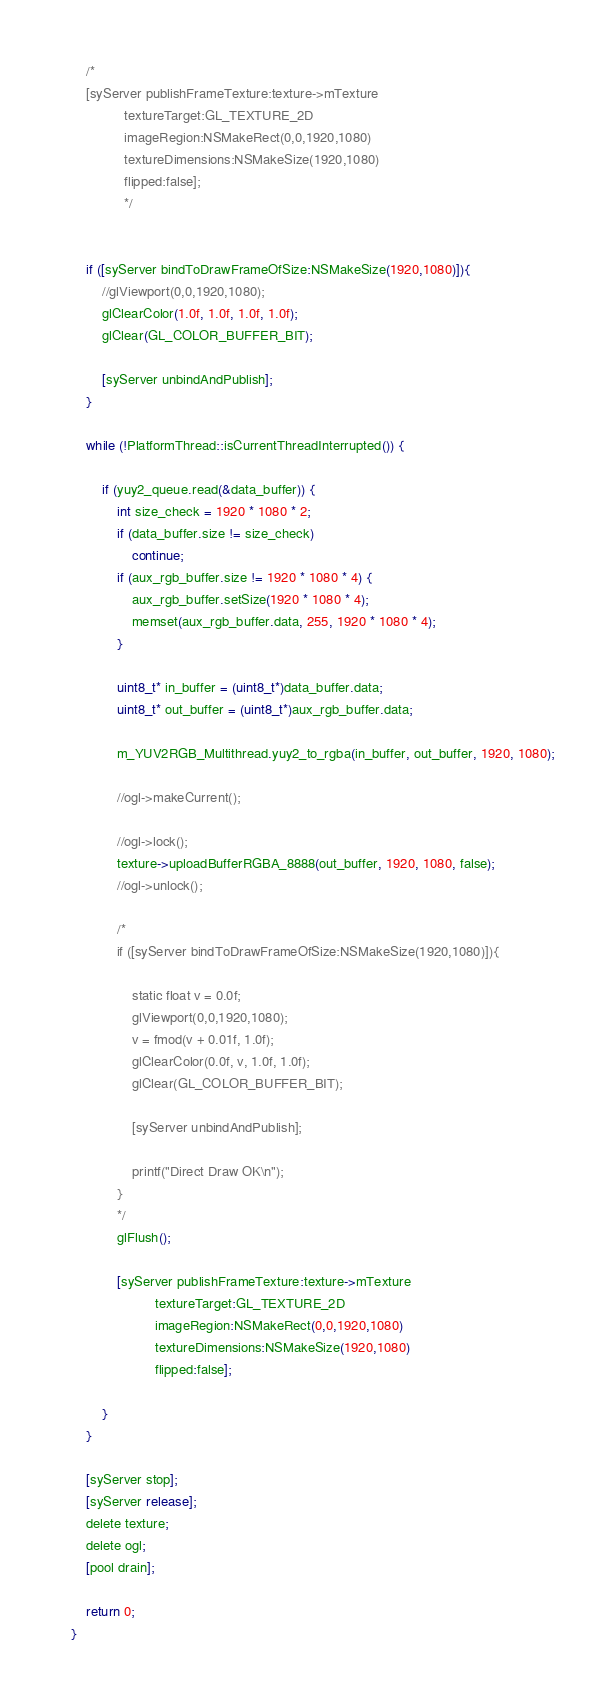<code> <loc_0><loc_0><loc_500><loc_500><_ObjectiveC_>    
    /*
    [syServer publishFrameTexture:texture->mTexture 
              textureTarget:GL_TEXTURE_2D 
              imageRegion:NSMakeRect(0,0,1920,1080)
              textureDimensions:NSMakeSize(1920,1080)
              flipped:false];
              */

    
    if ([syServer bindToDrawFrameOfSize:NSMakeSize(1920,1080)]){
        //glViewport(0,0,1920,1080);
        glClearColor(1.0f, 1.0f, 1.0f, 1.0f);
        glClear(GL_COLOR_BUFFER_BIT);
        
        [syServer unbindAndPublish];
    }

    while (!PlatformThread::isCurrentThreadInterrupted()) {
        
        if (yuy2_queue.read(&data_buffer)) {
            int size_check = 1920 * 1080 * 2;
            if (data_buffer.size != size_check)
                continue;
            if (aux_rgb_buffer.size != 1920 * 1080 * 4) {
                aux_rgb_buffer.setSize(1920 * 1080 * 4);
                memset(aux_rgb_buffer.data, 255, 1920 * 1080 * 4);
            }

            uint8_t* in_buffer = (uint8_t*)data_buffer.data;
            uint8_t* out_buffer = (uint8_t*)aux_rgb_buffer.data;
            
            m_YUV2RGB_Multithread.yuy2_to_rgba(in_buffer, out_buffer, 1920, 1080);

            //ogl->makeCurrent();
            
            //ogl->lock();
            texture->uploadBufferRGBA_8888(out_buffer, 1920, 1080, false);
            //ogl->unlock();

            /*
            if ([syServer bindToDrawFrameOfSize:NSMakeSize(1920,1080)]){

                static float v = 0.0f;
                glViewport(0,0,1920,1080);
                v = fmod(v + 0.01f, 1.0f);
                glClearColor(0.0f, v, 1.0f, 1.0f);
                glClear(GL_COLOR_BUFFER_BIT);

                [syServer unbindAndPublish];

                printf("Direct Draw OK\n");
            }
            */
            glFlush();

            [syServer publishFrameTexture:texture->mTexture 
                      textureTarget:GL_TEXTURE_2D
                      imageRegion:NSMakeRect(0,0,1920,1080)
                      textureDimensions:NSMakeSize(1920,1080)
                      flipped:false];

        }
    }

    [syServer stop];
    [syServer release];
    delete texture;
    delete ogl;
    [pool drain];

    return 0;
}</code> 